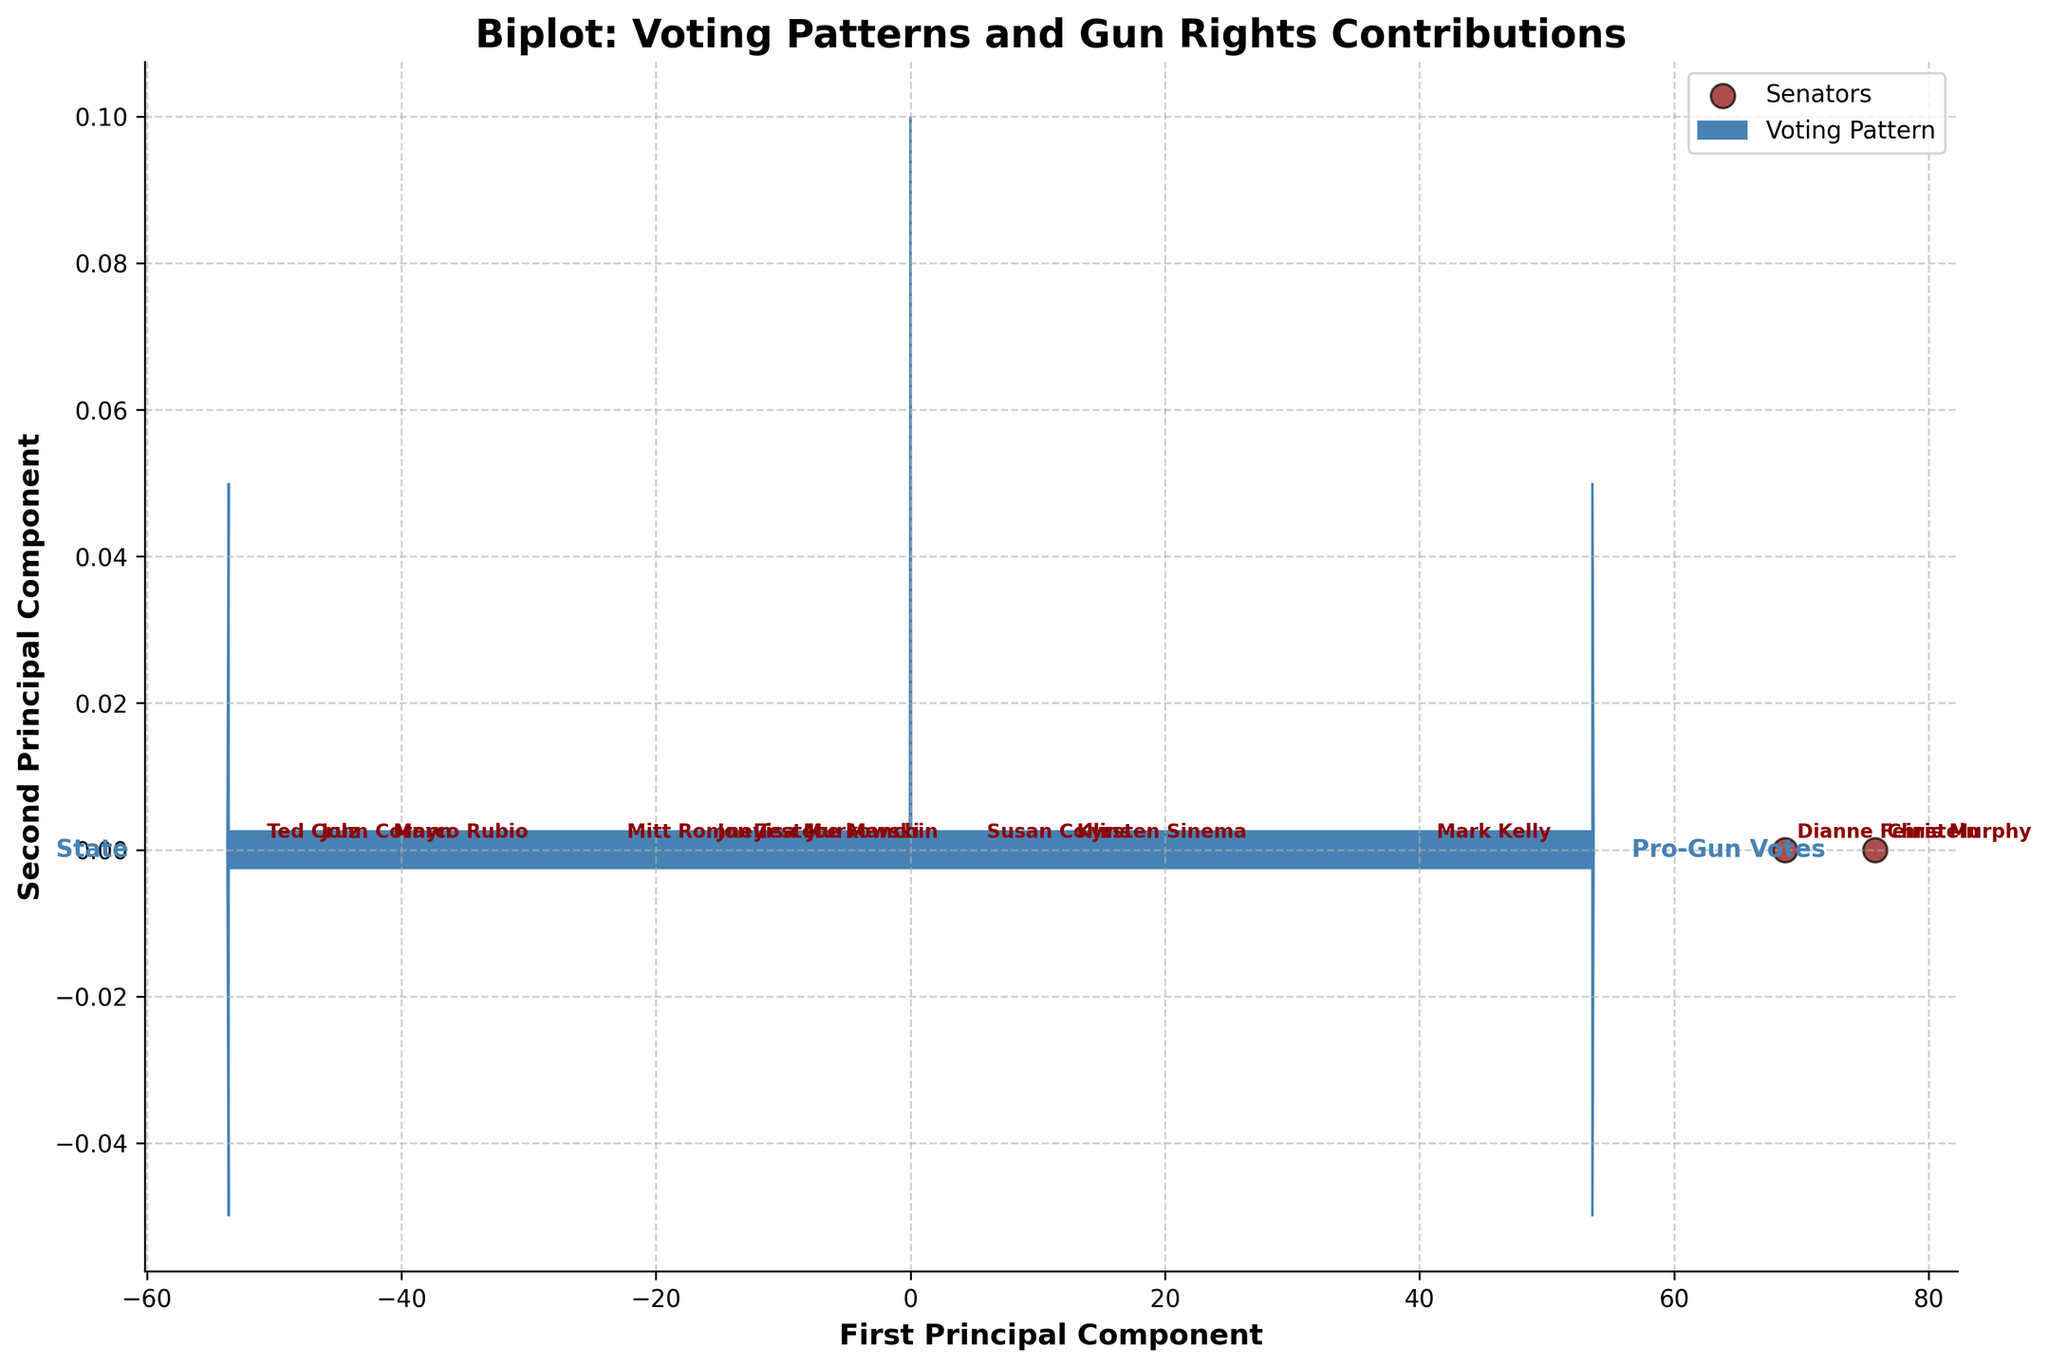Which senator has the highest number of pro-gun votes? By looking at the data points on the biplot, we can see the senator represented by Ted Cruz who is situated at the rightmost end corresponding to "Pro-Gun Votes" vector. This indicates he has the highest pro-gun votes.
Answer: Ted Cruz What do the arrows in the figure represent? The arrows in the biplot represent the variables "Pro-Gun Votes" and "Anti-Gun Votes." Their direction and length indicate the influence of these variables on the principal components.
Answer: Voting Patterns How do the pro-gun votes of Susan Collins compare to those of Mitt Romney? By comparing the positions of Susan Collins and Mitt Romney in the biplot, we see that Mitt Romney appears closer to the "Pro-Gun Votes" arrow, indicating he has more pro-gun votes than Susan Collins.
Answer: Mitt Romney has more pro-gun votes Who received the highest NRA contributions among the senators? Referring to the data points projected along the principal components, Ted Cruz is the farthest along and situated closely to the "NRA Contributions" axis vector, indicating he received the highest NRA contributions.
Answer: Ted Cruz What is the general correlation between pro-gun votes and NRA contributions? Observing the biplot, it appears that points with high pro-gun votes tend to be located closer to the "NRA Contributions" vector. This implies a positive correlation: as the number of pro-gun votes increases, NRA contributions also tend to increase.
Answer: Positive correlation How do Jon Tester and Mark Kelly differ in terms of voting patterns? Inspecting the positions of Jon Tester and Mark Kelly in the biplot, Jon Tester is closer to the "Pro-Gun Votes" axis whereas Mark Kelly is closer to the "Anti-Gun Votes" axis, indicating Jon Tester has more pro-gun votes and Mark Kelly has more anti-gun votes.
Answer: Jon Tester has more pro-gun votes; Mark Kelly has more anti-gun votes What is the average number of anti-gun votes for Chris Murphy and Dianne Feinstein? Looking at the data points corresponding to Chris Murphy and Dianne Feinstein, we see they are both aligned closely with the "Anti-Gun Votes" axis, indicating high values. The anti-gun votes are 95 for Chris Murphy and 90 for Dianne Feinstein, averaging (95 + 90) / 2 = 92.5.
Answer: 92.5 Which variable appears to have a stronger relationship with the first principal component? Observing the arrows representing "Pro-Gun Votes" and "Anti-Gun Votes," the "Pro-Gun Votes" arrow is longer and more aligned with the first principal component, indicating it has a stronger relationship.
Answer: Pro-Gun Votes Describe the position of Kyrsten Sinema in terms of voting patterns and contributions. Kyrsten Sinema is positioned centrally on the biplot, indicating a balance between pro-gun and anti-gun votes. Her position close to the origin on both the vectors suggests moderate NRA and GOA contributions.
Answer: Balanced voting, moderate contributions Which senator represented by the data seems to have voting patterns and contributions least aligned with pro-gun support? The biplot shows Dianne Feinstein positioned closest to the "Anti-Gun Votes" axis and far from both the "Pro-Gun Votes" and contribution vectors, indicating minimal alignment with pro-gun support.
Answer: Dianne Feinstein 